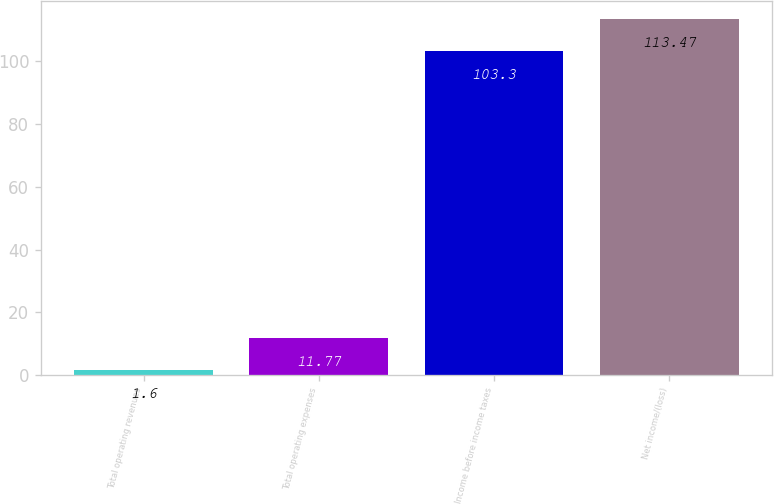<chart> <loc_0><loc_0><loc_500><loc_500><bar_chart><fcel>Total operating revenues<fcel>Total operating expenses<fcel>Income before income taxes<fcel>Net income/(loss)<nl><fcel>1.6<fcel>11.77<fcel>103.3<fcel>113.47<nl></chart> 